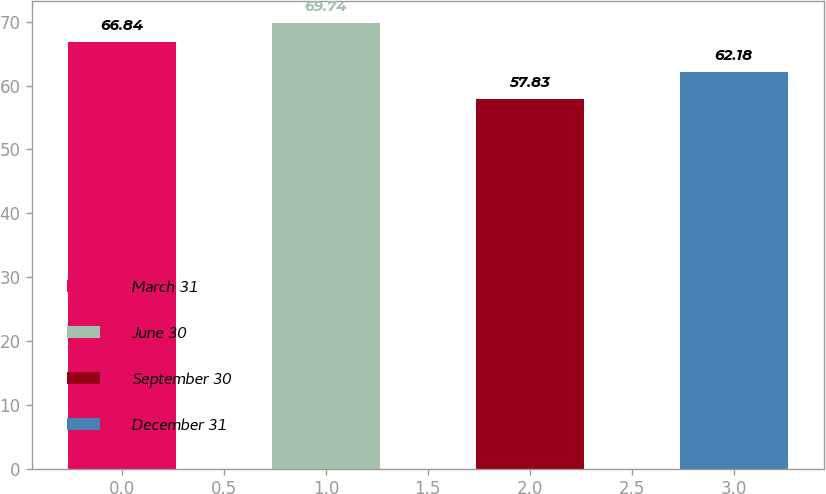Convert chart. <chart><loc_0><loc_0><loc_500><loc_500><bar_chart><fcel>March 31<fcel>June 30<fcel>September 30<fcel>December 31<nl><fcel>66.84<fcel>69.74<fcel>57.83<fcel>62.18<nl></chart> 